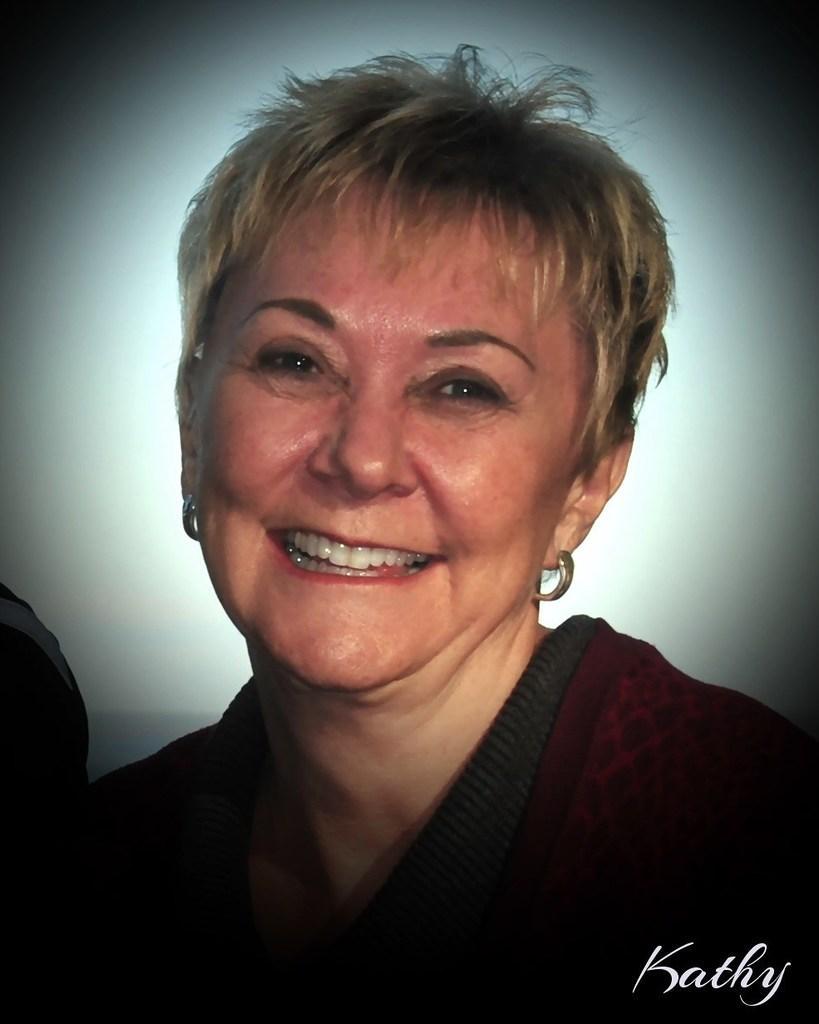Could you give a brief overview of what you see in this image? In this image I can see a woman and I can see smile on her face. Here I can see watermark and I can see this image is little bit in dark. 